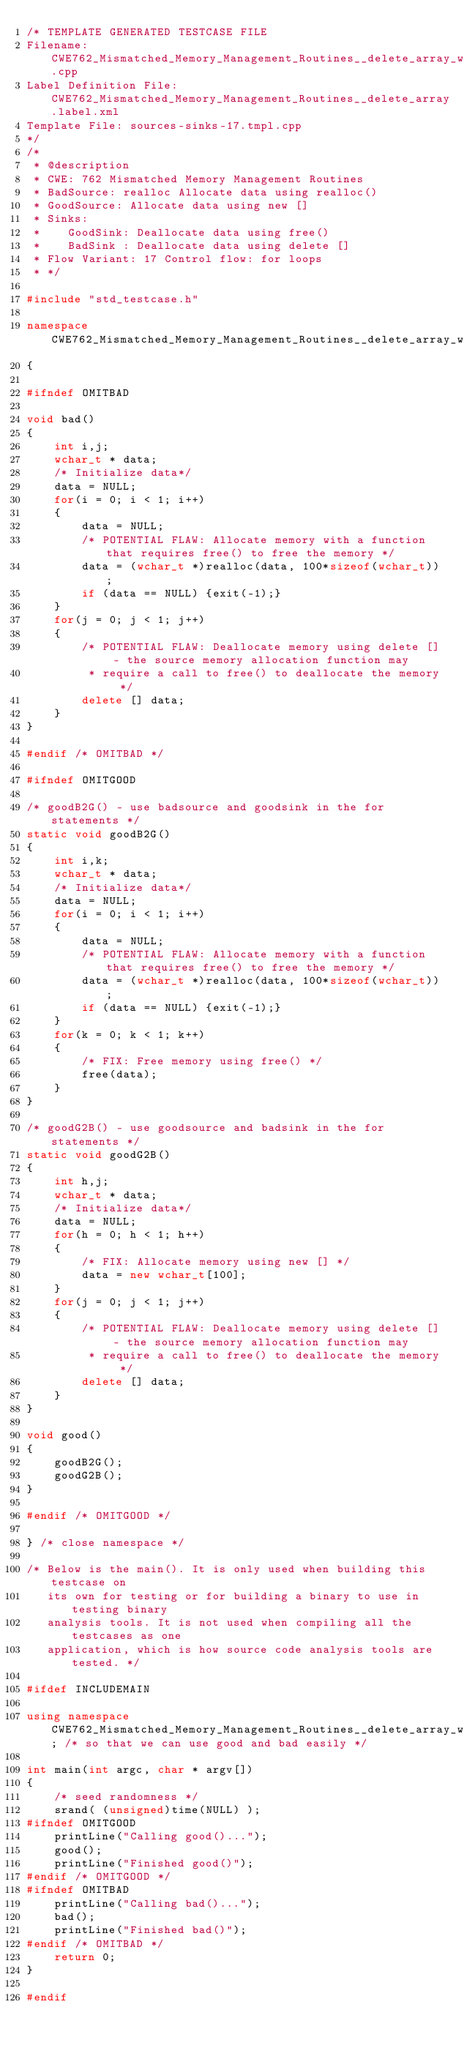<code> <loc_0><loc_0><loc_500><loc_500><_C++_>/* TEMPLATE GENERATED TESTCASE FILE
Filename: CWE762_Mismatched_Memory_Management_Routines__delete_array_wchar_t_realloc_17.cpp
Label Definition File: CWE762_Mismatched_Memory_Management_Routines__delete_array.label.xml
Template File: sources-sinks-17.tmpl.cpp
*/
/*
 * @description
 * CWE: 762 Mismatched Memory Management Routines
 * BadSource: realloc Allocate data using realloc()
 * GoodSource: Allocate data using new []
 * Sinks:
 *    GoodSink: Deallocate data using free()
 *    BadSink : Deallocate data using delete []
 * Flow Variant: 17 Control flow: for loops
 * */

#include "std_testcase.h"

namespace CWE762_Mismatched_Memory_Management_Routines__delete_array_wchar_t_realloc_17
{

#ifndef OMITBAD

void bad()
{
    int i,j;
    wchar_t * data;
    /* Initialize data*/
    data = NULL;
    for(i = 0; i < 1; i++)
    {
        data = NULL;
        /* POTENTIAL FLAW: Allocate memory with a function that requires free() to free the memory */
        data = (wchar_t *)realloc(data, 100*sizeof(wchar_t));
        if (data == NULL) {exit(-1);}
    }
    for(j = 0; j < 1; j++)
    {
        /* POTENTIAL FLAW: Deallocate memory using delete [] - the source memory allocation function may
         * require a call to free() to deallocate the memory */
        delete [] data;
    }
}

#endif /* OMITBAD */

#ifndef OMITGOOD

/* goodB2G() - use badsource and goodsink in the for statements */
static void goodB2G()
{
    int i,k;
    wchar_t * data;
    /* Initialize data*/
    data = NULL;
    for(i = 0; i < 1; i++)
    {
        data = NULL;
        /* POTENTIAL FLAW: Allocate memory with a function that requires free() to free the memory */
        data = (wchar_t *)realloc(data, 100*sizeof(wchar_t));
        if (data == NULL) {exit(-1);}
    }
    for(k = 0; k < 1; k++)
    {
        /* FIX: Free memory using free() */
        free(data);
    }
}

/* goodG2B() - use goodsource and badsink in the for statements */
static void goodG2B()
{
    int h,j;
    wchar_t * data;
    /* Initialize data*/
    data = NULL;
    for(h = 0; h < 1; h++)
    {
        /* FIX: Allocate memory using new [] */
        data = new wchar_t[100];
    }
    for(j = 0; j < 1; j++)
    {
        /* POTENTIAL FLAW: Deallocate memory using delete [] - the source memory allocation function may
         * require a call to free() to deallocate the memory */
        delete [] data;
    }
}

void good()
{
    goodB2G();
    goodG2B();
}

#endif /* OMITGOOD */

} /* close namespace */

/* Below is the main(). It is only used when building this testcase on
   its own for testing or for building a binary to use in testing binary
   analysis tools. It is not used when compiling all the testcases as one
   application, which is how source code analysis tools are tested. */

#ifdef INCLUDEMAIN

using namespace CWE762_Mismatched_Memory_Management_Routines__delete_array_wchar_t_realloc_17; /* so that we can use good and bad easily */

int main(int argc, char * argv[])
{
    /* seed randomness */
    srand( (unsigned)time(NULL) );
#ifndef OMITGOOD
    printLine("Calling good()...");
    good();
    printLine("Finished good()");
#endif /* OMITGOOD */
#ifndef OMITBAD
    printLine("Calling bad()...");
    bad();
    printLine("Finished bad()");
#endif /* OMITBAD */
    return 0;
}

#endif
</code> 